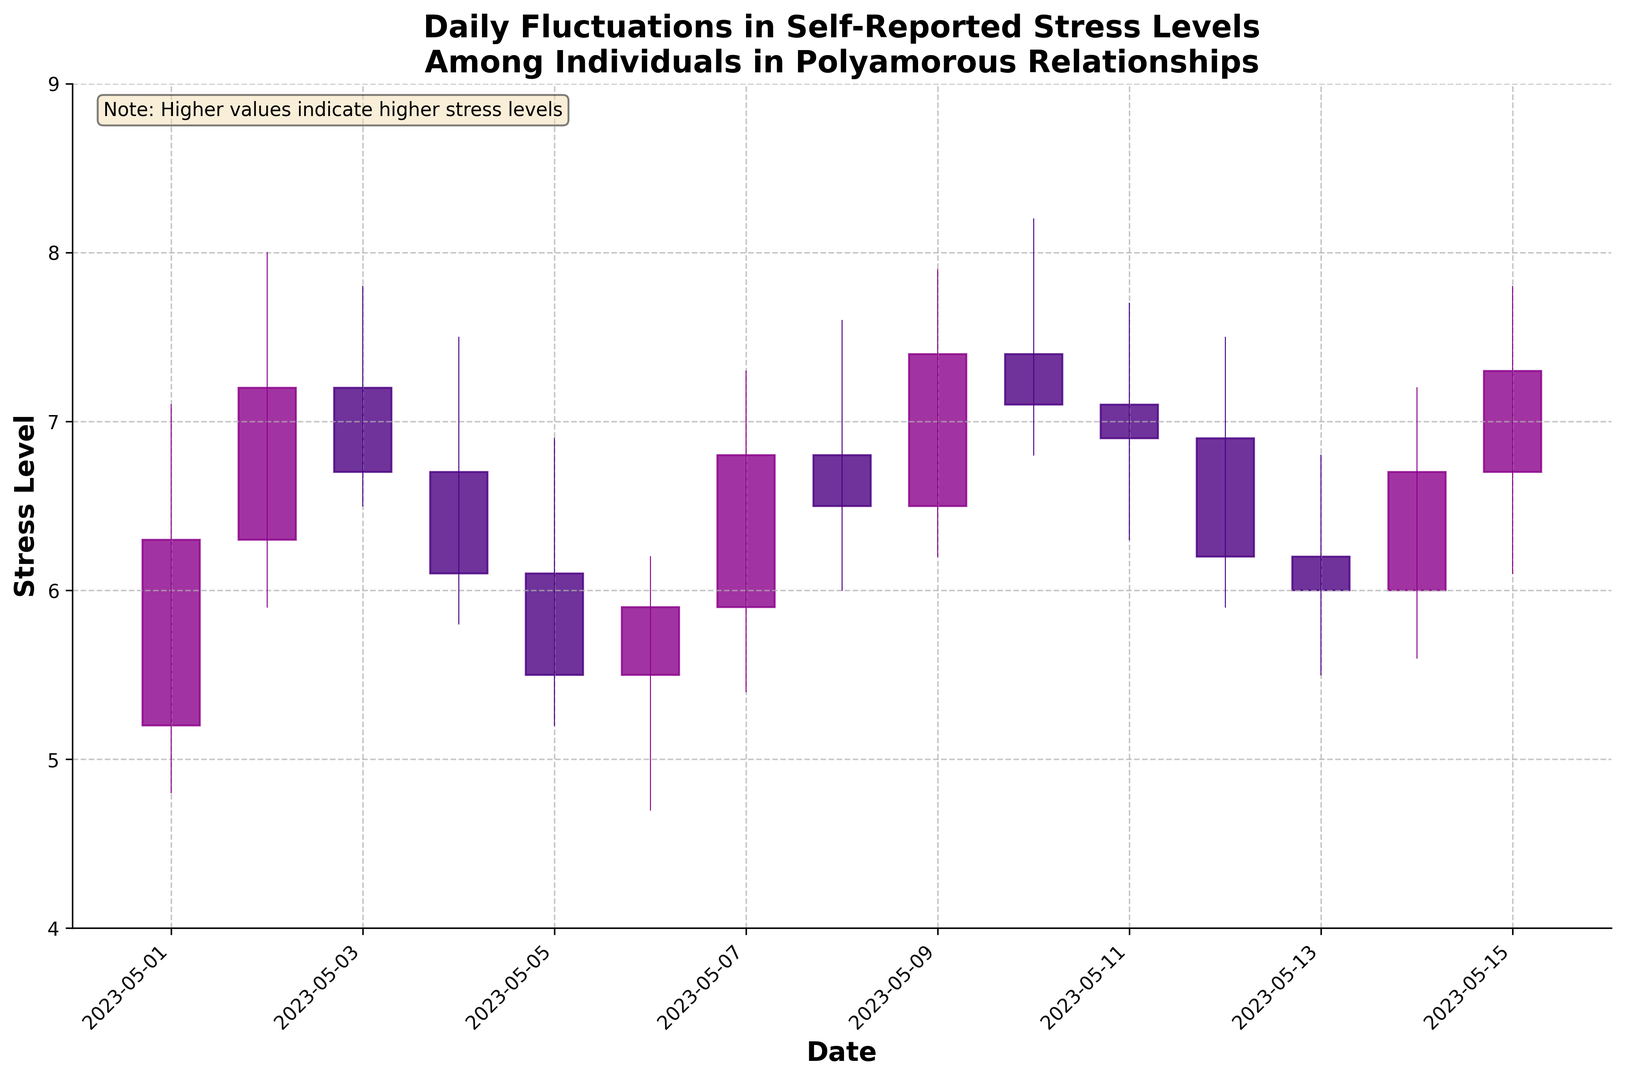What was the highest stress level recorded and on which date did it occur? The highest stress level can be identified by looking at the tallest candlestick. The high value of 8.2 on 2023-05-10 is the highest recorded stress level.
Answer: 8.2 on 2023-05-10 On which date did the stress level have the largest range, and what was that range? The range is calculated by subtracting the low value from the high value for each day. The date with the largest range is 2023-05-10 with a high of 8.2 and a low of 6.8, so the range is 8.2 - 6.8 = 1.4.
Answer: 2023-05-10, range of 1.4 Which day experienced the greatest decrease in stress level from open to close? To determine the greatest decrease, find the biggest difference where the close value is less than the open value. The largest decrease is on 2023-05-04, where the stress level dropped from 6.7 to 6.1, a decrease of 6.7 - 6.1 = 0.6.
Answer: 2023-05-04, decrease of 0.6 What is the overall trend in stress levels from May 1st to May 15th? By examining the opening and closing values of the first and last days, the stress level opens at 5.2 on May 1st and closes at 7.3 on May 15th, indicating an increasing trend over the period.
Answer: Increasing trend Compare the stress levels on May 7th and May 8th. Which day had higher fluctuations and by how much? Fluctuations are measured by the range (high - low). May 7th has a range of 7.3 - 5.4 = 1.9, and May 8th has a range of 7.6 - 6.0 = 1.6. May 7th had higher fluctuations by 0.3 (1.9 - 1.6).
Answer: May 7th by 0.3 What was the average closing stress level for the period shown? To find the average, sum the closing values and divide by the number of days. The closing values are 6.3, 7.2, 6.7, 6.1, 5.5, 5.9, 6.8, 6.5, 7.4, 7.1, 6.9, 6.2, 6.0, 6.7, 7.3. The sum is 96.6, and there are 15 days, so the average is 96.6 / 15 = 6.44.
Answer: 6.44 Which candle has the longest body and what does this indicate about that day? The body is the distance between the open and close values. The day with the longest body is 2023-05-02, where the body is 8.0 - 6.3 = 1.7, indicating a significant increase in stress levels on that day.
Answer: 2023-05-02, significant increase What are the colors of the candlesticks that indicate an increase in stress level, and how many such candlesticks are there? The color indicating an increase in stress level is '#8B008B' (dark magenta for colorup). There are 8 such candlesticks, on 2023-05-01, 2023-05-02, 2023-05-06, 2023-05-07, 2023-05-08, 2023-05-09, 2023-05-11, and 2023-05-15.
Answer: Dark magenta, 8 candlesticks 